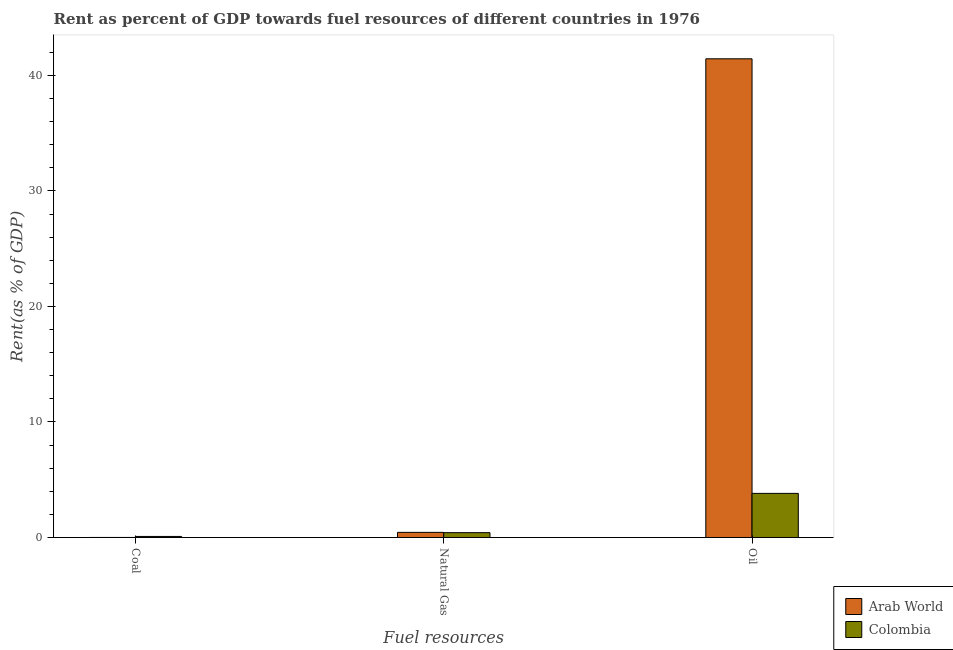How many groups of bars are there?
Your answer should be very brief. 3. How many bars are there on the 2nd tick from the left?
Offer a terse response. 2. How many bars are there on the 1st tick from the right?
Your answer should be compact. 2. What is the label of the 3rd group of bars from the left?
Provide a short and direct response. Oil. What is the rent towards natural gas in Arab World?
Your answer should be very brief. 0.44. Across all countries, what is the maximum rent towards oil?
Your answer should be very brief. 41.44. Across all countries, what is the minimum rent towards natural gas?
Your response must be concise. 0.42. In which country was the rent towards coal minimum?
Provide a succinct answer. Arab World. What is the total rent towards natural gas in the graph?
Offer a very short reply. 0.86. What is the difference between the rent towards coal in Colombia and that in Arab World?
Your answer should be very brief. 0.09. What is the difference between the rent towards natural gas in Colombia and the rent towards coal in Arab World?
Offer a very short reply. 0.41. What is the average rent towards coal per country?
Your answer should be very brief. 0.05. What is the difference between the rent towards oil and rent towards natural gas in Colombia?
Give a very brief answer. 3.4. In how many countries, is the rent towards natural gas greater than 20 %?
Offer a terse response. 0. What is the ratio of the rent towards coal in Colombia to that in Arab World?
Offer a terse response. 32.21. Is the difference between the rent towards natural gas in Colombia and Arab World greater than the difference between the rent towards coal in Colombia and Arab World?
Offer a very short reply. No. What is the difference between the highest and the second highest rent towards natural gas?
Your answer should be very brief. 0.03. What is the difference between the highest and the lowest rent towards coal?
Offer a terse response. 0.09. Is the sum of the rent towards coal in Colombia and Arab World greater than the maximum rent towards oil across all countries?
Keep it short and to the point. No. What does the 2nd bar from the left in Coal represents?
Offer a terse response. Colombia. What does the 2nd bar from the right in Natural Gas represents?
Keep it short and to the point. Arab World. How many countries are there in the graph?
Ensure brevity in your answer.  2. What is the difference between two consecutive major ticks on the Y-axis?
Your answer should be very brief. 10. Are the values on the major ticks of Y-axis written in scientific E-notation?
Your answer should be compact. No. Does the graph contain any zero values?
Your answer should be compact. No. How are the legend labels stacked?
Provide a succinct answer. Vertical. What is the title of the graph?
Provide a short and direct response. Rent as percent of GDP towards fuel resources of different countries in 1976. What is the label or title of the X-axis?
Ensure brevity in your answer.  Fuel resources. What is the label or title of the Y-axis?
Your answer should be compact. Rent(as % of GDP). What is the Rent(as % of GDP) in Arab World in Coal?
Ensure brevity in your answer.  0. What is the Rent(as % of GDP) of Colombia in Coal?
Make the answer very short. 0.09. What is the Rent(as % of GDP) of Arab World in Natural Gas?
Provide a short and direct response. 0.44. What is the Rent(as % of GDP) of Colombia in Natural Gas?
Provide a succinct answer. 0.42. What is the Rent(as % of GDP) of Arab World in Oil?
Offer a terse response. 41.44. What is the Rent(as % of GDP) in Colombia in Oil?
Make the answer very short. 3.82. Across all Fuel resources, what is the maximum Rent(as % of GDP) of Arab World?
Provide a short and direct response. 41.44. Across all Fuel resources, what is the maximum Rent(as % of GDP) in Colombia?
Keep it short and to the point. 3.82. Across all Fuel resources, what is the minimum Rent(as % of GDP) in Arab World?
Offer a terse response. 0. Across all Fuel resources, what is the minimum Rent(as % of GDP) of Colombia?
Make the answer very short. 0.09. What is the total Rent(as % of GDP) of Arab World in the graph?
Your answer should be compact. 41.88. What is the total Rent(as % of GDP) of Colombia in the graph?
Your answer should be very brief. 4.33. What is the difference between the Rent(as % of GDP) in Arab World in Coal and that in Natural Gas?
Your answer should be compact. -0.44. What is the difference between the Rent(as % of GDP) in Colombia in Coal and that in Natural Gas?
Offer a very short reply. -0.33. What is the difference between the Rent(as % of GDP) in Arab World in Coal and that in Oil?
Offer a very short reply. -41.43. What is the difference between the Rent(as % of GDP) in Colombia in Coal and that in Oil?
Keep it short and to the point. -3.73. What is the difference between the Rent(as % of GDP) in Arab World in Natural Gas and that in Oil?
Provide a short and direct response. -40.99. What is the difference between the Rent(as % of GDP) in Arab World in Coal and the Rent(as % of GDP) in Colombia in Natural Gas?
Provide a short and direct response. -0.41. What is the difference between the Rent(as % of GDP) of Arab World in Coal and the Rent(as % of GDP) of Colombia in Oil?
Give a very brief answer. -3.81. What is the difference between the Rent(as % of GDP) of Arab World in Natural Gas and the Rent(as % of GDP) of Colombia in Oil?
Keep it short and to the point. -3.37. What is the average Rent(as % of GDP) in Arab World per Fuel resources?
Your response must be concise. 13.96. What is the average Rent(as % of GDP) of Colombia per Fuel resources?
Your answer should be very brief. 1.44. What is the difference between the Rent(as % of GDP) in Arab World and Rent(as % of GDP) in Colombia in Coal?
Make the answer very short. -0.09. What is the difference between the Rent(as % of GDP) of Arab World and Rent(as % of GDP) of Colombia in Natural Gas?
Ensure brevity in your answer.  0.03. What is the difference between the Rent(as % of GDP) of Arab World and Rent(as % of GDP) of Colombia in Oil?
Offer a very short reply. 37.62. What is the ratio of the Rent(as % of GDP) of Arab World in Coal to that in Natural Gas?
Provide a succinct answer. 0.01. What is the ratio of the Rent(as % of GDP) of Colombia in Coal to that in Natural Gas?
Make the answer very short. 0.22. What is the ratio of the Rent(as % of GDP) in Colombia in Coal to that in Oil?
Provide a succinct answer. 0.02. What is the ratio of the Rent(as % of GDP) in Arab World in Natural Gas to that in Oil?
Your answer should be compact. 0.01. What is the ratio of the Rent(as % of GDP) in Colombia in Natural Gas to that in Oil?
Offer a very short reply. 0.11. What is the difference between the highest and the second highest Rent(as % of GDP) in Arab World?
Your answer should be compact. 40.99. What is the difference between the highest and the lowest Rent(as % of GDP) in Arab World?
Keep it short and to the point. 41.43. What is the difference between the highest and the lowest Rent(as % of GDP) of Colombia?
Keep it short and to the point. 3.73. 